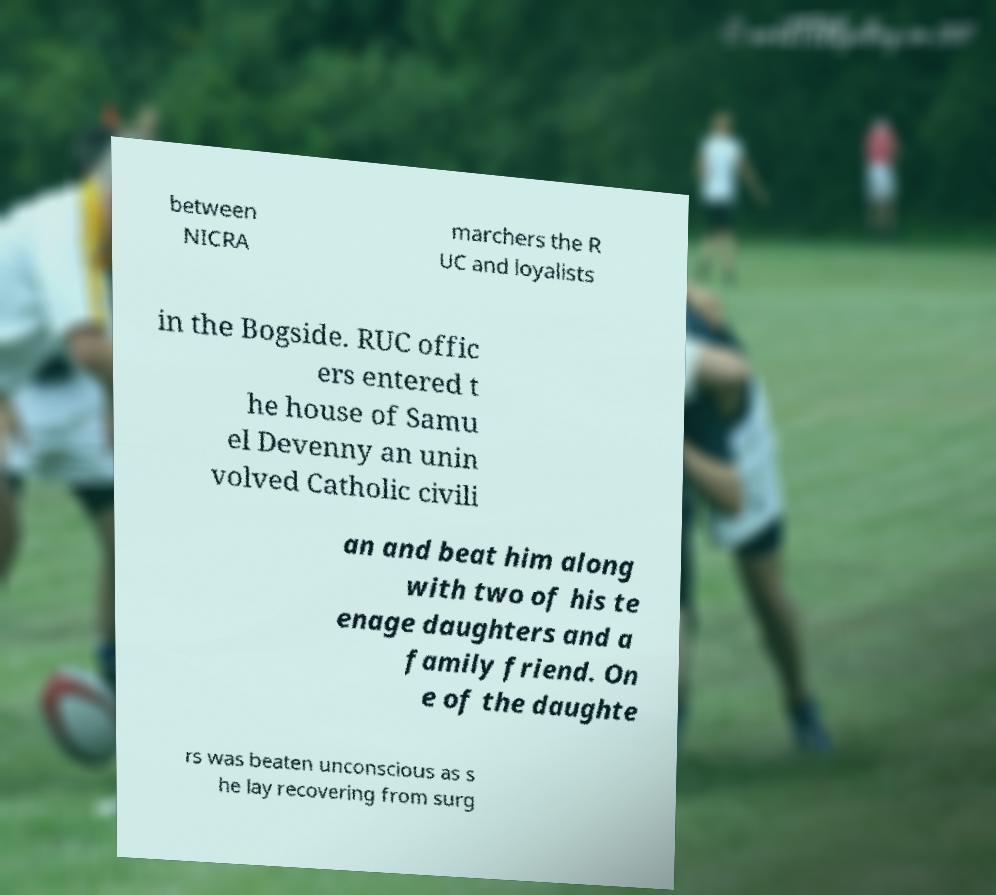I need the written content from this picture converted into text. Can you do that? between NICRA marchers the R UC and loyalists in the Bogside. RUC offic ers entered t he house of Samu el Devenny an unin volved Catholic civili an and beat him along with two of his te enage daughters and a family friend. On e of the daughte rs was beaten unconscious as s he lay recovering from surg 